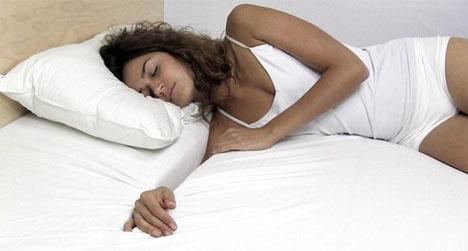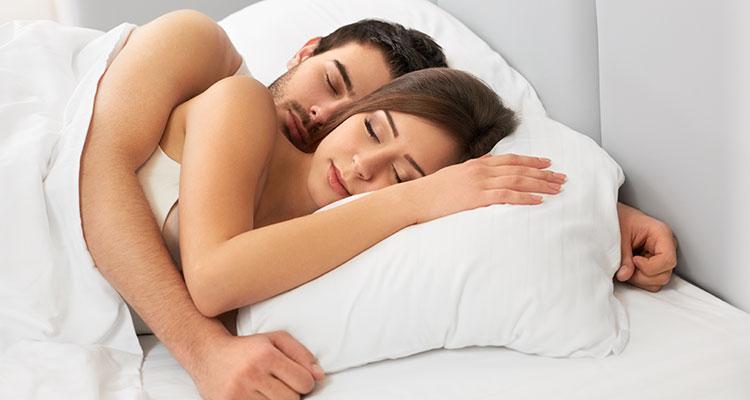The first image is the image on the left, the second image is the image on the right. Analyze the images presented: Is the assertion "A woman is lying on her left side with a pillow as large as her." valid? Answer yes or no. No. The first image is the image on the left, the second image is the image on the right. Considering the images on both sides, is "There are three people." valid? Answer yes or no. Yes. 